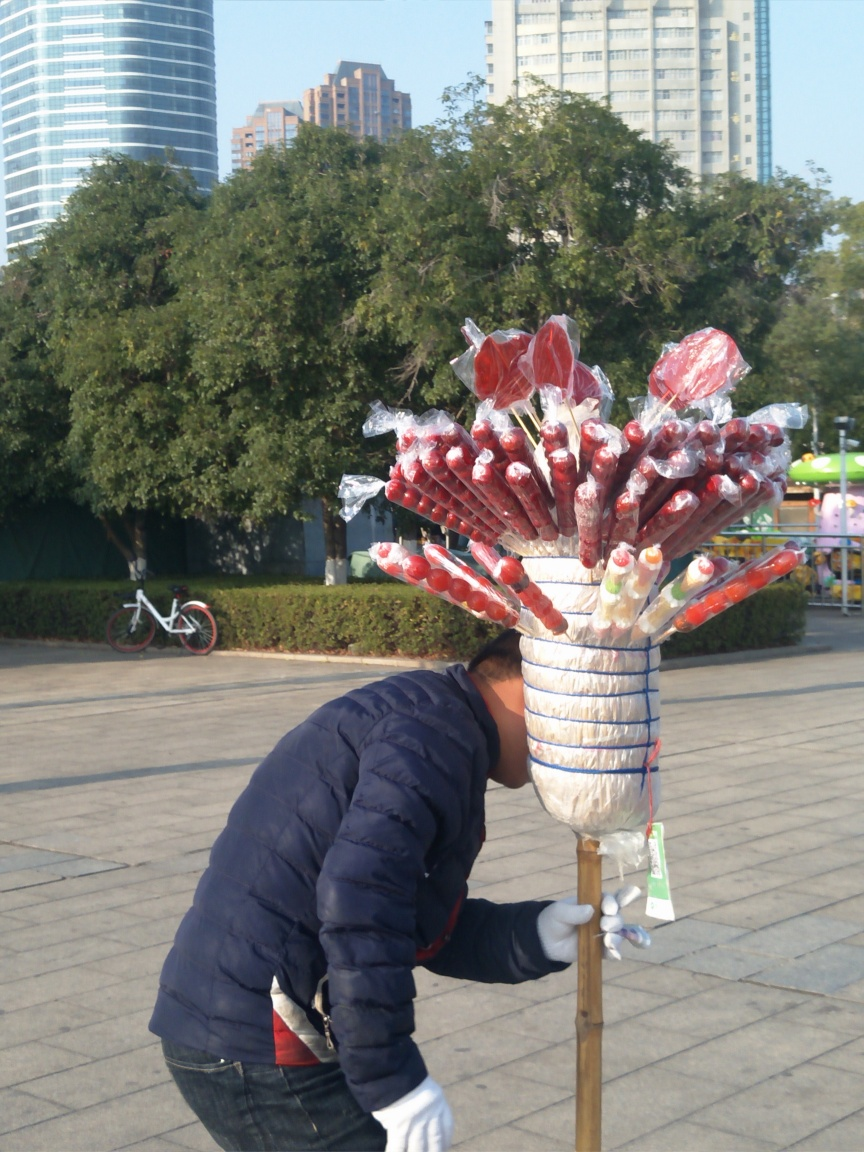Can you tell me more about the setting where this photo was taken? The photo seems to have been taken in an urban park with neatly trimmed grass and a walking path. In the background, we can see a mix of modern high-rise buildings and more traditional, shorter structures, indicating a city environment that blends different architectural styles. Does the presence of the candy apple stand suggest anything about the time of year or local culture? Candy apples are often associated with fall and festive seasons, suggesting this might be a time when people come to enjoy such treats. Additionally, the stand suggests a cultural preference for street food vendors and public snacking, which is common in many urban environments across the world. 